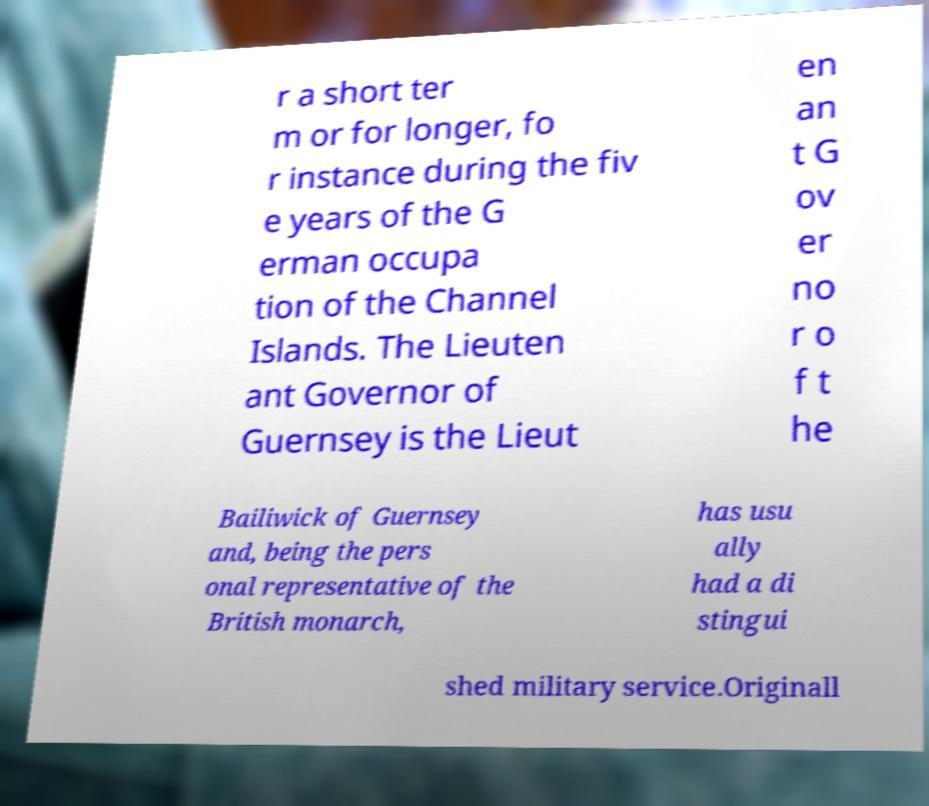Please read and relay the text visible in this image. What does it say? r a short ter m or for longer, fo r instance during the fiv e years of the G erman occupa tion of the Channel Islands. The Lieuten ant Governor of Guernsey is the Lieut en an t G ov er no r o f t he Bailiwick of Guernsey and, being the pers onal representative of the British monarch, has usu ally had a di stingui shed military service.Originall 